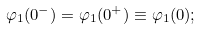Convert formula to latex. <formula><loc_0><loc_0><loc_500><loc_500>\varphi _ { 1 } ( 0 ^ { - } ) = \varphi _ { 1 } ( 0 ^ { + } ) \equiv \varphi _ { 1 } ( 0 ) ;</formula> 